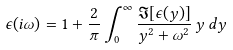Convert formula to latex. <formula><loc_0><loc_0><loc_500><loc_500>\epsilon ( i \omega ) = 1 + \frac { 2 } { \pi } \int _ { 0 } ^ { \infty } \frac { \Im [ \epsilon ( y ) ] } { y ^ { 2 } + \omega ^ { 2 } } \, y \, d y</formula> 